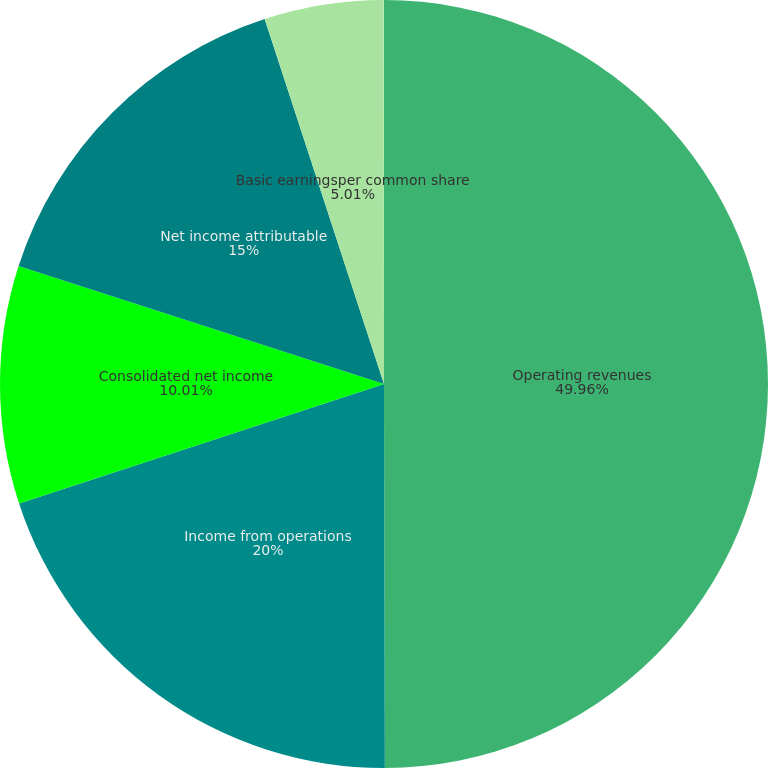Convert chart to OTSL. <chart><loc_0><loc_0><loc_500><loc_500><pie_chart><fcel>Operating revenues<fcel>Income from operations<fcel>Consolidated net income<fcel>Net income attributable<fcel>Basic earningsper common share<fcel>Diluted earningsper common<nl><fcel>49.97%<fcel>20.0%<fcel>10.01%<fcel>15.0%<fcel>5.01%<fcel>0.02%<nl></chart> 